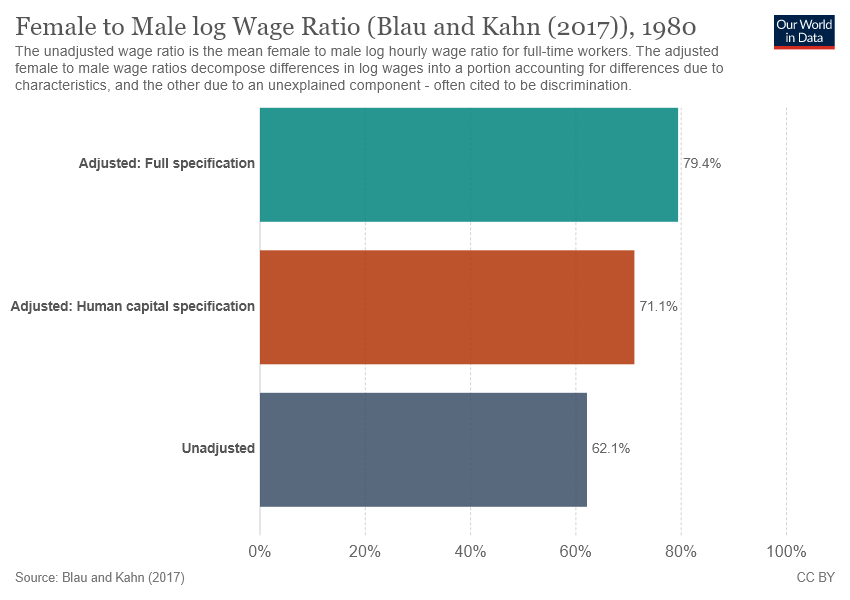Specify some key components in this picture. The average of the smallest two bars is not greater than the value of the largest bar. The value of Middle bar is 71.1, as indicated by the display. 